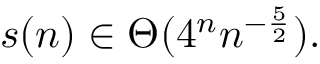Convert formula to latex. <formula><loc_0><loc_0><loc_500><loc_500>s ( n ) \in \Theta ( 4 ^ { n } n ^ { - { \frac { 5 } { 2 } } } ) .</formula> 